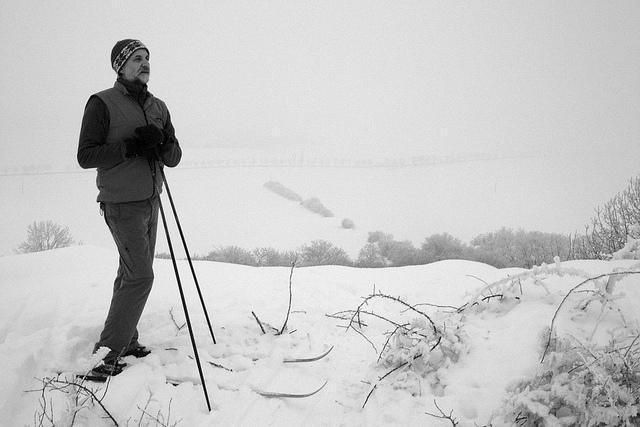How many people are visible?
Give a very brief answer. 1. 